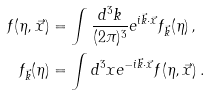Convert formula to latex. <formula><loc_0><loc_0><loc_500><loc_500>f ( \eta , \vec { x } ) & = \int { \frac { d ^ { 3 } k } { ( 2 \pi ) ^ { 3 } } e ^ { i \vec { k } \cdot \vec { x } } f _ { \vec { k } } ( \eta ) } \, , \\ f _ { \vec { k } } ( \eta ) & = \int { d ^ { 3 } x e ^ { - i \vec { k } \cdot \vec { x } } f ( \eta , \vec { x } ) } \, .</formula> 